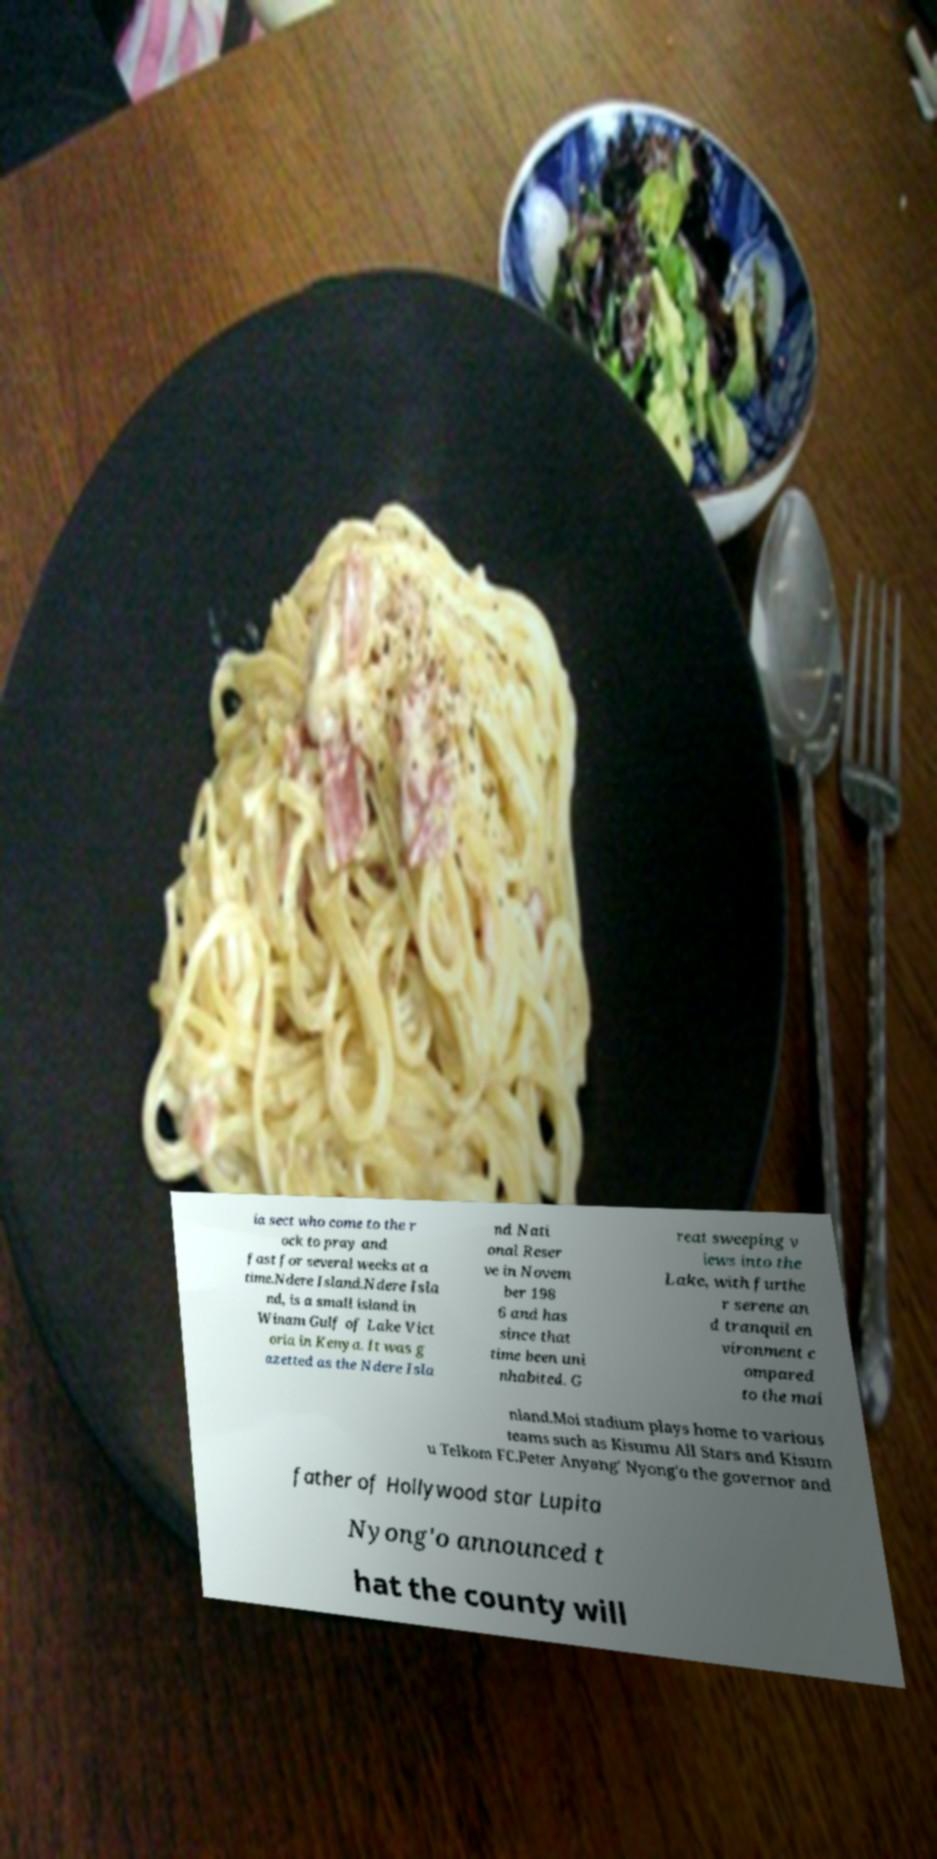Could you extract and type out the text from this image? ia sect who come to the r ock to pray and fast for several weeks at a time.Ndere Island.Ndere Isla nd, is a small island in Winam Gulf of Lake Vict oria in Kenya. It was g azetted as the Ndere Isla nd Nati onal Reser ve in Novem ber 198 6 and has since that time been uni nhabited. G reat sweeping v iews into the Lake, with furthe r serene an d tranquil en vironment c ompared to the mai nland.Moi stadium plays home to various teams such as Kisumu All Stars and Kisum u Telkom FC.Peter Anyang' Nyong'o the governor and father of Hollywood star Lupita Nyong'o announced t hat the county will 